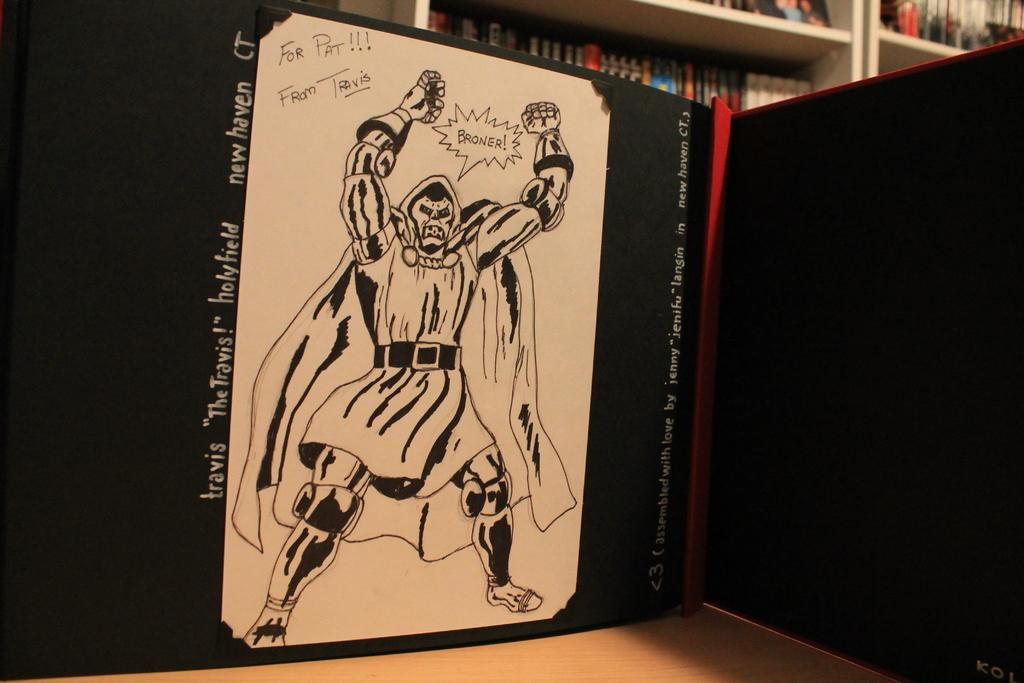<image>
Summarize the visual content of the image. A drawing of Doctor Doom that was done for Pat. 